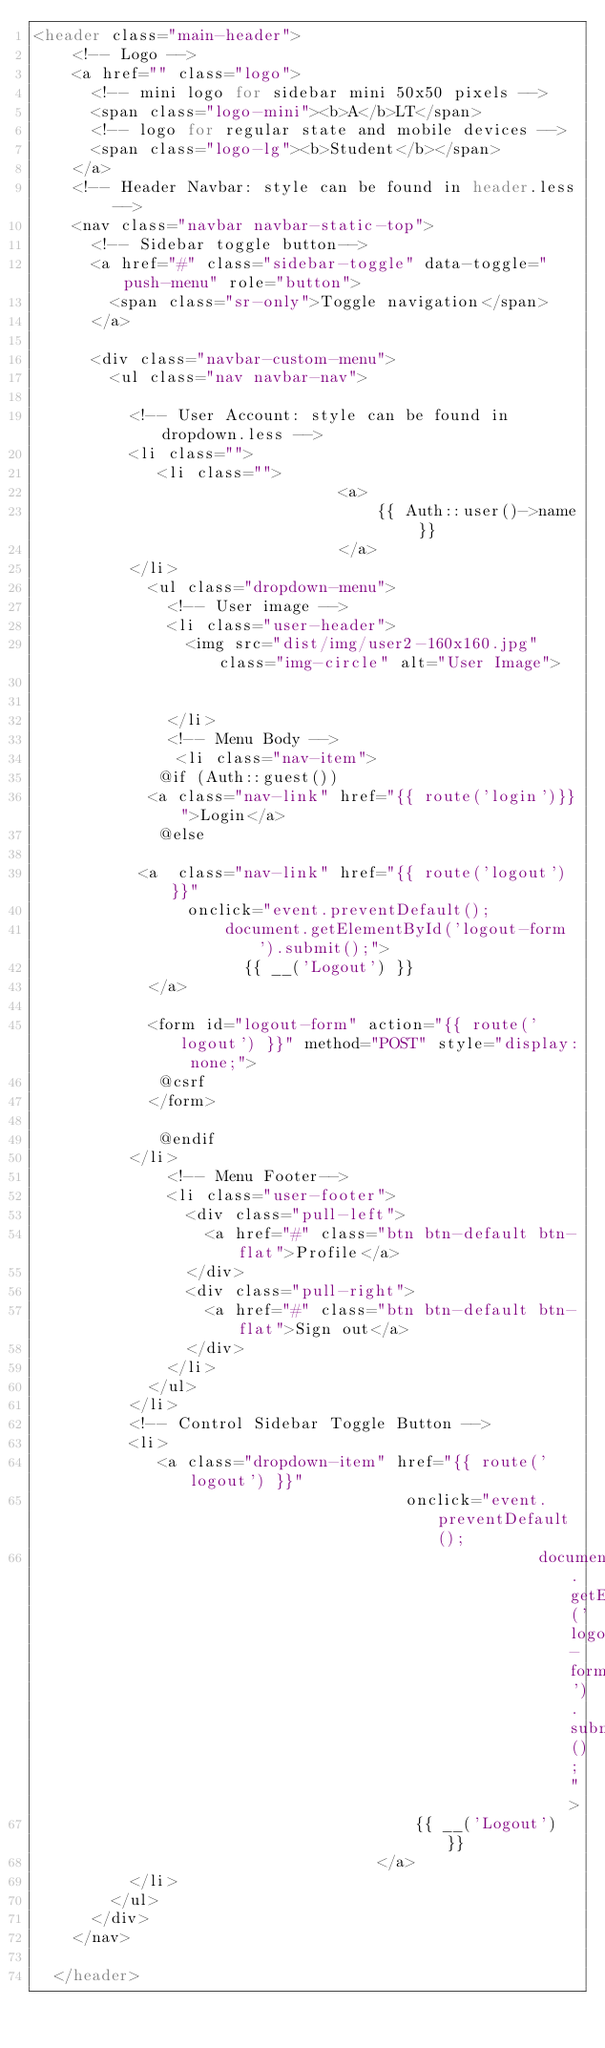Convert code to text. <code><loc_0><loc_0><loc_500><loc_500><_PHP_><header class="main-header">
    <!-- Logo -->
    <a href="" class="logo">
      <!-- mini logo for sidebar mini 50x50 pixels -->
      <span class="logo-mini"><b>A</b>LT</span>
      <!-- logo for regular state and mobile devices -->
      <span class="logo-lg"><b>Student</b></span>
    </a>
    <!-- Header Navbar: style can be found in header.less -->
    <nav class="navbar navbar-static-top">
      <!-- Sidebar toggle button-->
      <a href="#" class="sidebar-toggle" data-toggle="push-menu" role="button">
        <span class="sr-only">Toggle navigation</span>
      </a>

      <div class="navbar-custom-menu">
        <ul class="nav navbar-nav">
         
          <!-- User Account: style can be found in dropdown.less -->
          <li class="">
             <li class="">
                                <a>
                                    {{ Auth::user()->name }}
                                </a>
          </li>
            <ul class="dropdown-menu">
              <!-- User image -->
              <li class="user-header">
                <img src="dist/img/user2-160x160.jpg" class="img-circle" alt="User Image">

                
              </li>
              <!-- Menu Body -->
               <li class="nav-item">
             @if (Auth::guest())
            <a class="nav-link" href="{{ route('login')}}">Login</a>
             @else
             
           <a  class="nav-link" href="{{ route('logout') }}"
                onclick="event.preventDefault();
                    document.getElementById('logout-form').submit();">
                      {{ __('Logout') }}
            </a>

            <form id="logout-form" action="{{ route('logout') }}" method="POST" style="display: none;">
             @csrf
            </form>

             @endif
          </li>
              <!-- Menu Footer-->
              <li class="user-footer">
                <div class="pull-left">
                  <a href="#" class="btn btn-default btn-flat">Profile</a>
                </div>
                <div class="pull-right">
                  <a href="#" class="btn btn-default btn-flat">Sign out</a>
                </div>
              </li>
            </ul>
          </li>
          <!-- Control Sidebar Toggle Button -->
          <li>
             <a class="dropdown-item" href="{{ route('logout') }}"
                                       onclick="event.preventDefault();
                                                     document.getElementById('logout-form').submit();">
                                        {{ __('Logout') }}
                                    </a>
          </li>
        </ul>
      </div>
    </nav>
     
  </header>


  </code> 